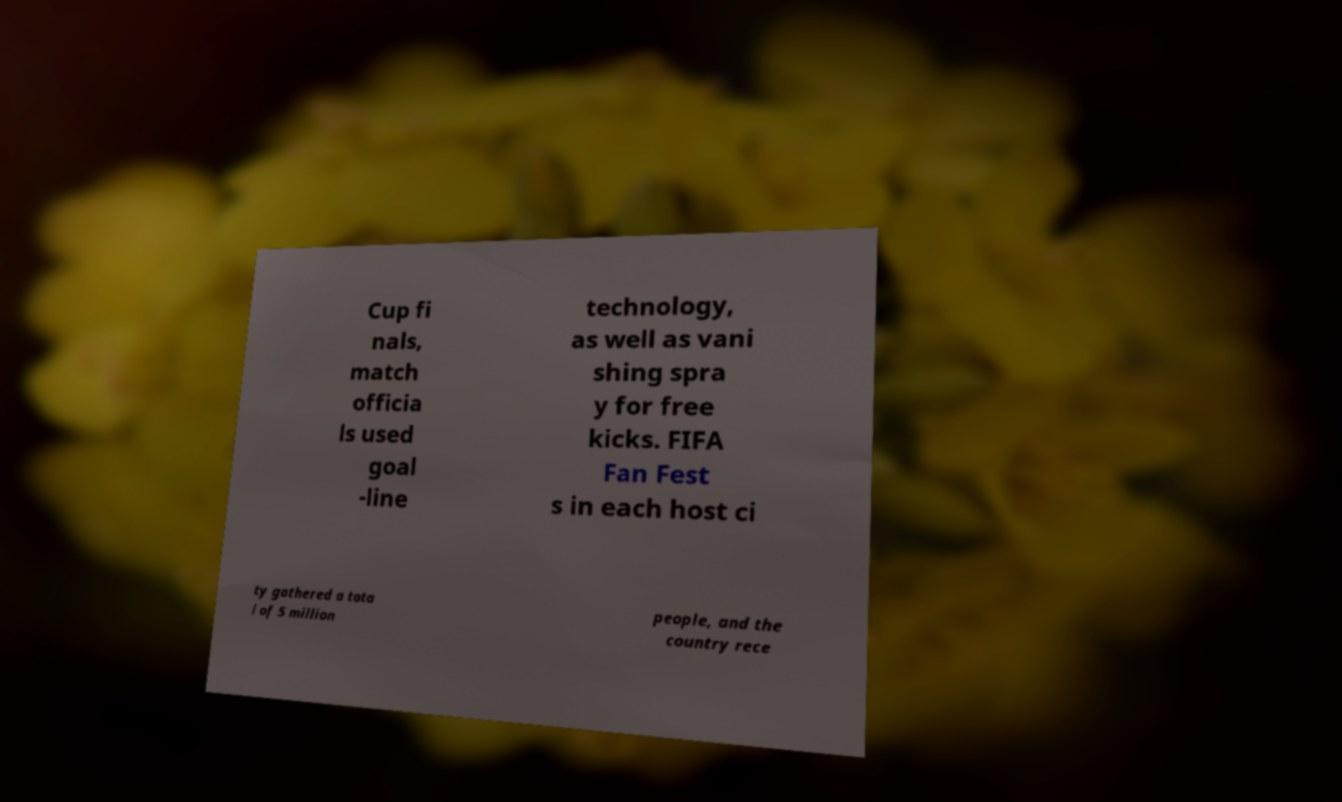Can you read and provide the text displayed in the image?This photo seems to have some interesting text. Can you extract and type it out for me? Cup fi nals, match officia ls used goal -line technology, as well as vani shing spra y for free kicks. FIFA Fan Fest s in each host ci ty gathered a tota l of 5 million people, and the country rece 